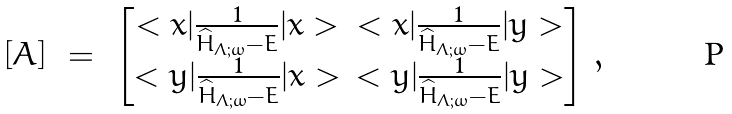<formula> <loc_0><loc_0><loc_500><loc_500>[ A ] \ = \ \begin{bmatrix} < x | \frac { 1 } { \widehat { H } _ { \Lambda ; \omega } - E } | x > & < x | \frac { 1 } { \widehat { H } _ { \Lambda ; \omega } - E } | y > \\ < y | \frac { 1 } { \widehat { H } _ { \Lambda ; \omega } - E } | x > & < y | \frac { 1 } { \widehat { H } _ { \Lambda ; \omega } - E } | y > \end{bmatrix} \, ,</formula> 